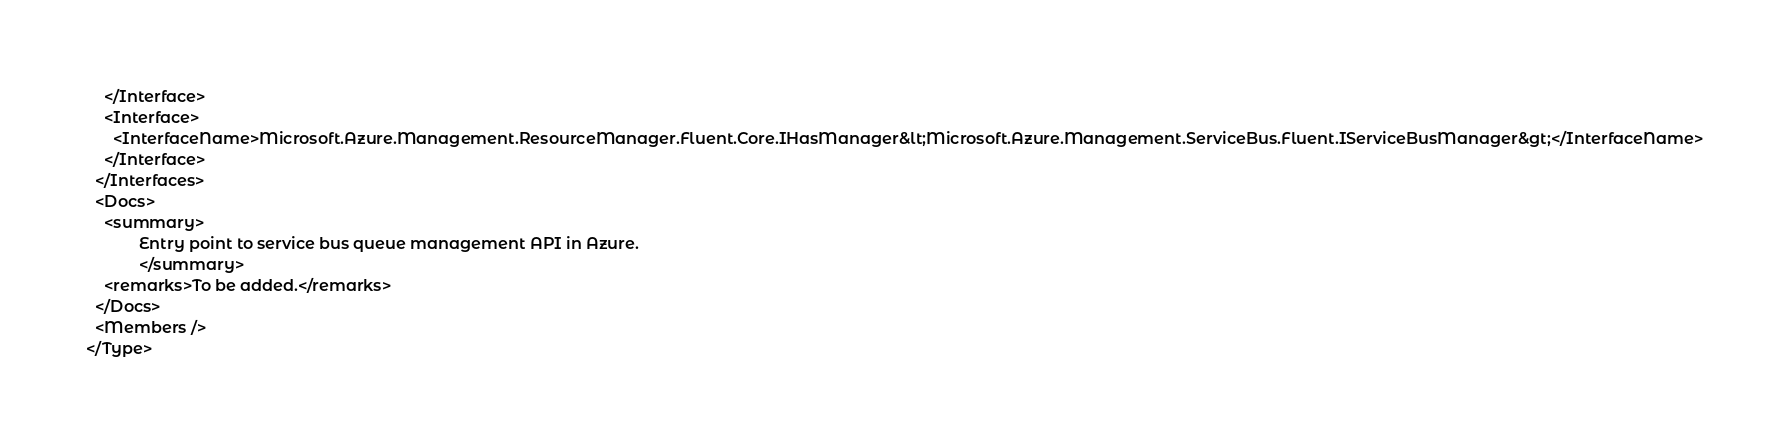Convert code to text. <code><loc_0><loc_0><loc_500><loc_500><_XML_>    </Interface>
    <Interface>
      <InterfaceName>Microsoft.Azure.Management.ResourceManager.Fluent.Core.IHasManager&lt;Microsoft.Azure.Management.ServiceBus.Fluent.IServiceBusManager&gt;</InterfaceName>
    </Interface>
  </Interfaces>
  <Docs>
    <summary>
            Entry point to service bus queue management API in Azure.
            </summary>
    <remarks>To be added.</remarks>
  </Docs>
  <Members />
</Type>
</code> 